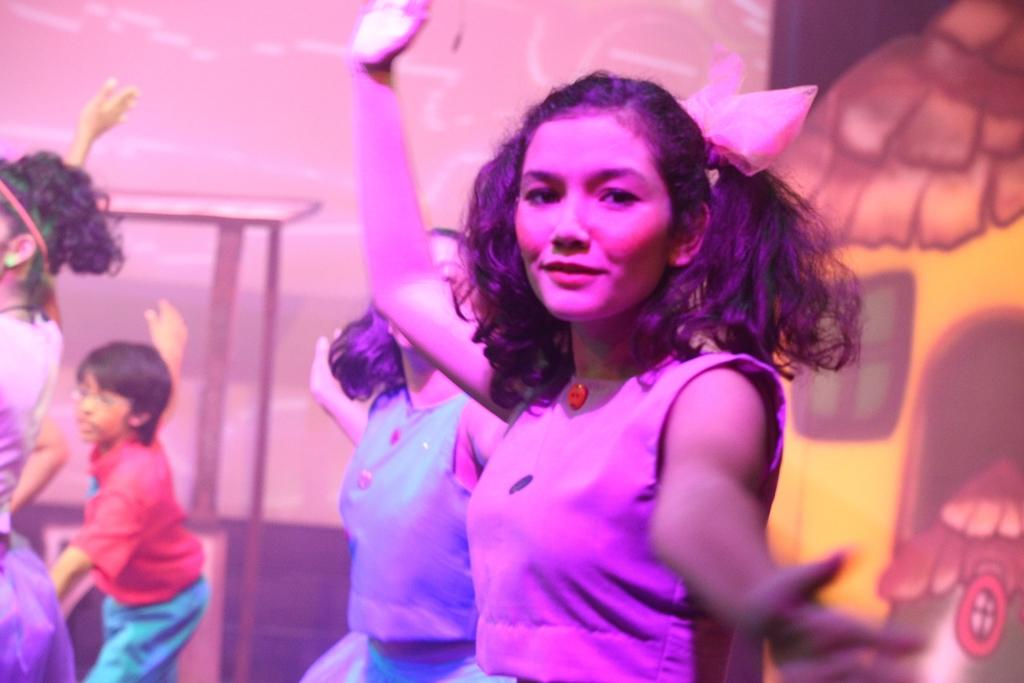What are the people in the image doing? The girls and the boy are dancing in the image. How many people are present in the image? There are four people in the image: three girls and one boy. What is visible on the wall in the image? There are paintings on the wall in the image. What type of wine is being served at the event in the image? There is no reference to any wine or event in the image. What type of wool is being used to make the sweaters worn by the girls in the image? There is no mention of any sweaters or wool in the image. 